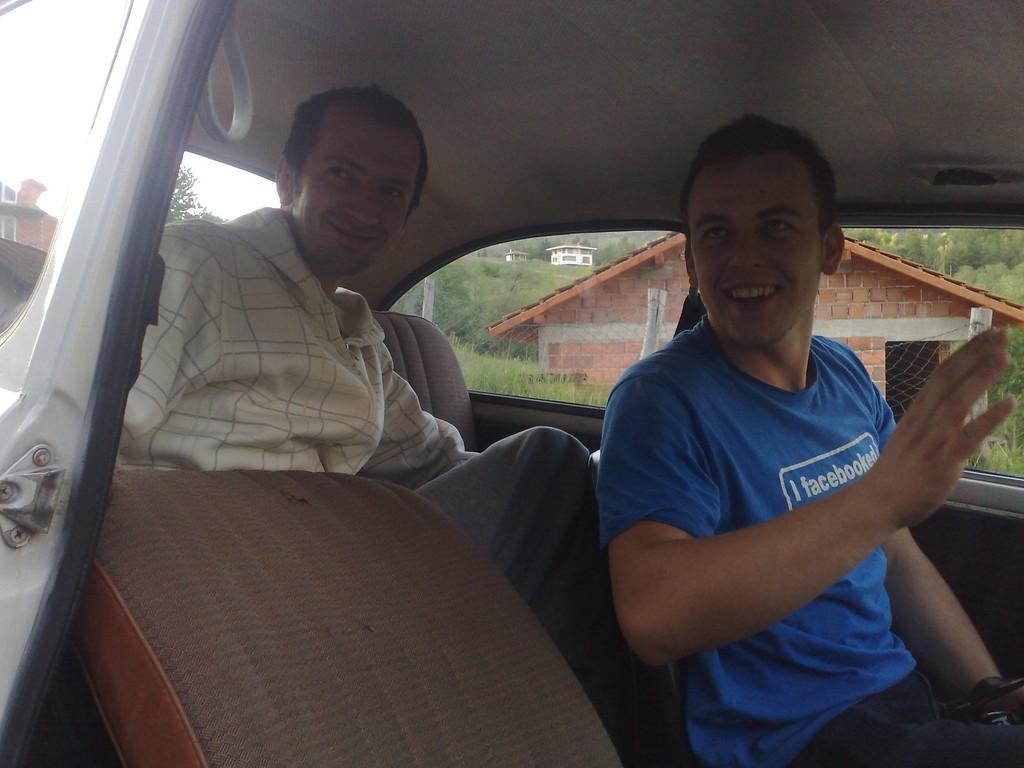Describe this image in one or two sentences. In this image we can see two people sitting inside the car and in the background there are few buildings, grass, trees and sky. 